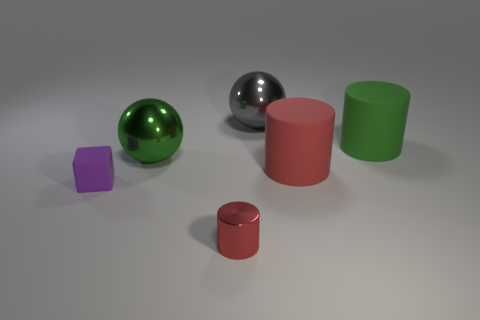Add 4 red metal things. How many objects exist? 10 Subtract all balls. How many objects are left? 4 Add 1 cylinders. How many cylinders are left? 4 Add 2 green matte cylinders. How many green matte cylinders exist? 3 Subtract 0 gray cylinders. How many objects are left? 6 Subtract all red rubber things. Subtract all big green shiny objects. How many objects are left? 4 